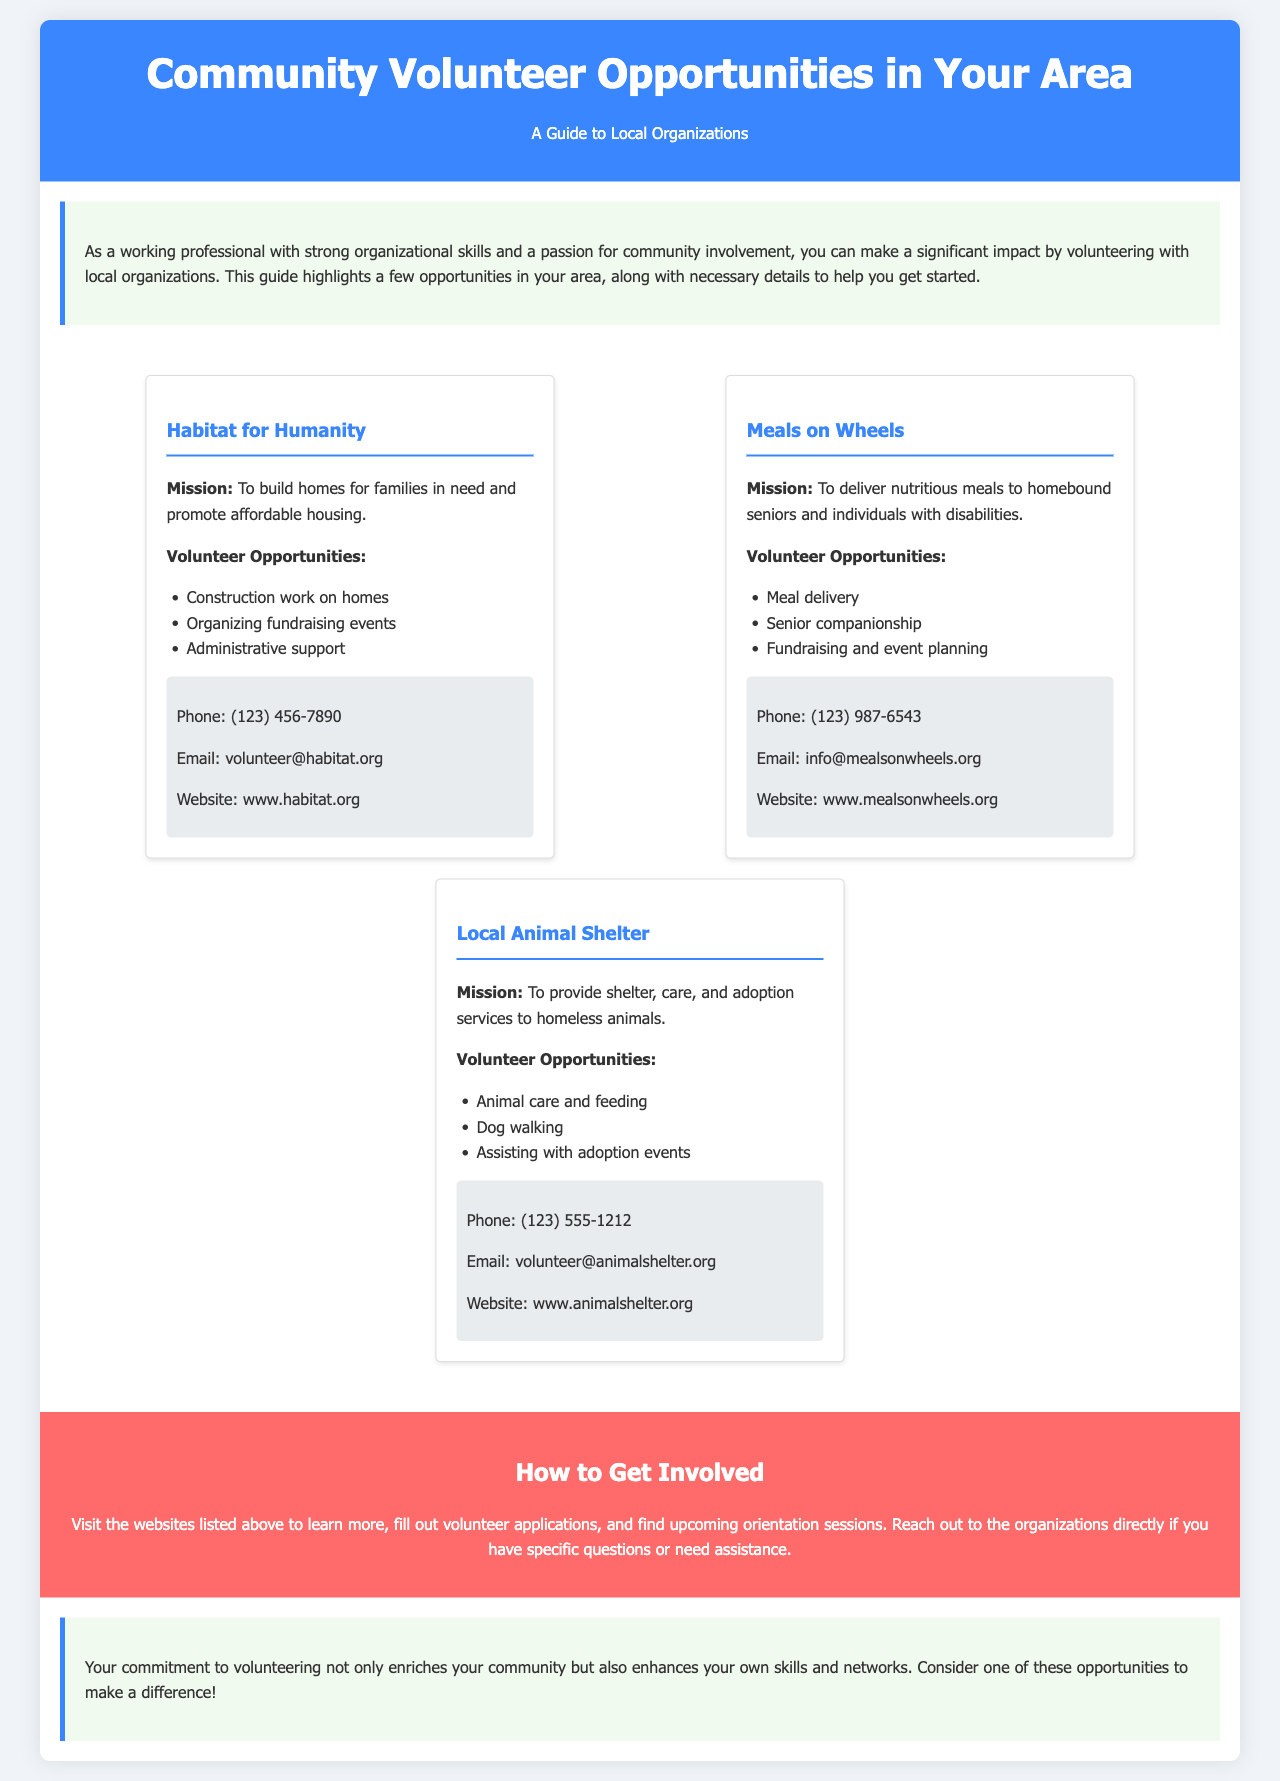what is the mission of Habitat for Humanity? The mission of Habitat for Humanity is to build homes for families in need and promote affordable housing.
Answer: build homes for families in need and promote affordable housing how many volunteer opportunities are listed for Meals on Wheels? Meals on Wheels has three volunteer opportunities mentioned in the document: meal delivery, senior companionship, and fundraising and event planning.
Answer: 3 what is the contact phone number for the Local Animal Shelter? The phone number listed for the Local Animal Shelter is (123) 555-1212.
Answer: (123) 555-1212 which organization focuses on delivering meals to homebound seniors? The organization that focuses on delivering meals to homebound seniors is Meals on Wheels.
Answer: Meals on Wheels what type of work can you do with Habitat for Humanity? You can participate in construction work on homes, organize fundraising events, or provide administrative support.
Answer: construction work on homes, organizing fundraising events, administrative support how to get involved with these organizations? To get involved, you can visit the websites to learn more, fill out volunteer applications, and find upcoming orientation sessions.
Answer: Visit the websites listed above what is the color of the brochure header? The color of the brochure header is blue, specifically #3a86ff.
Answer: blue which opportunity involves animal care? The opportunity that involves animal care is found at the Local Animal Shelter.
Answer: Local Animal Shelter 